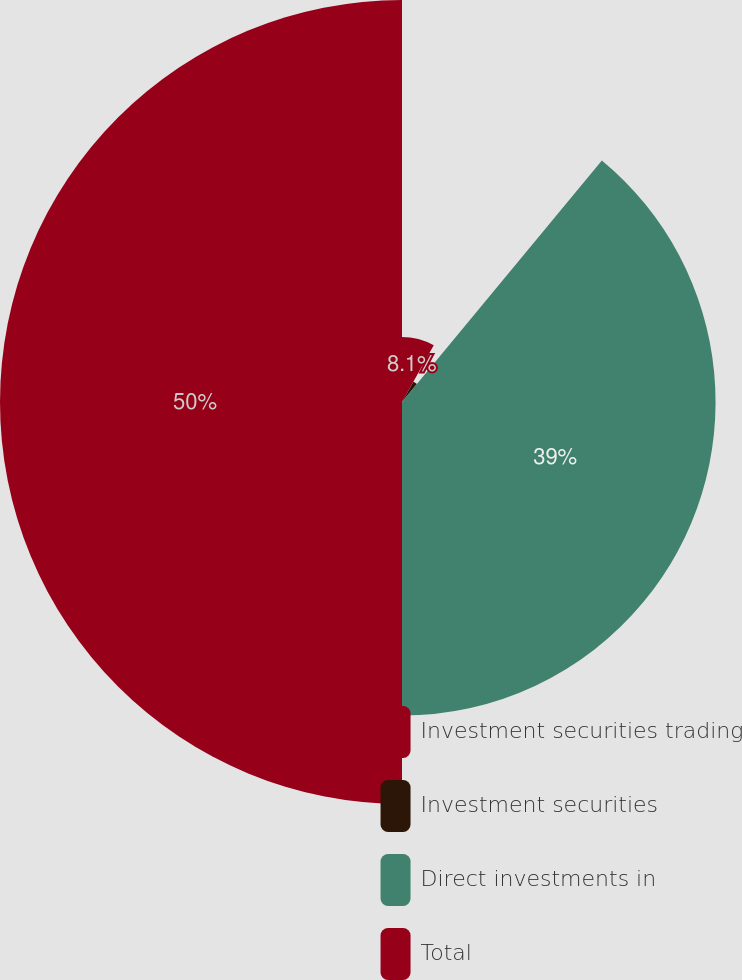<chart> <loc_0><loc_0><loc_500><loc_500><pie_chart><fcel>Investment securities trading<fcel>Investment securities<fcel>Direct investments in<fcel>Total<nl><fcel>8.1%<fcel>2.9%<fcel>39.0%<fcel>50.0%<nl></chart> 